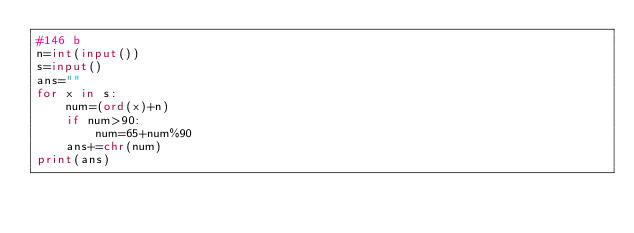Convert code to text. <code><loc_0><loc_0><loc_500><loc_500><_Python_>#146 b
n=int(input())
s=input()
ans=""
for x in s:
    num=(ord(x)+n)
    if num>90:
        num=65+num%90
    ans+=chr(num)
print(ans)</code> 